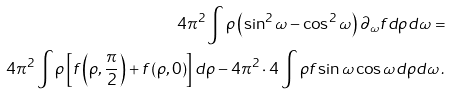Convert formula to latex. <formula><loc_0><loc_0><loc_500><loc_500>4 \pi ^ { 2 } \int \rho \left ( \sin ^ { 2 } \omega - \cos ^ { 2 } \omega \right ) \partial _ { \omega } f d \rho d \omega = \\ 4 \pi ^ { 2 } \int \rho \left [ f \left ( \rho , \frac { \pi } { 2 } \right ) + f \left ( \rho , 0 \right ) \right ] d \rho - 4 \pi ^ { 2 } \cdot 4 \int \rho f \sin \omega \cos \omega d \rho d \omega \, .</formula> 